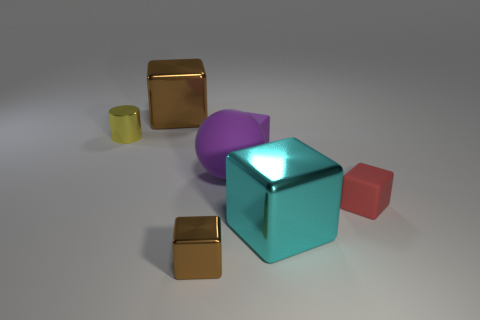There is a thing that is the same color as the small metal block; what is its material?
Provide a short and direct response. Metal. There is a big shiny object that is behind the cyan object; is its shape the same as the large object that is in front of the rubber ball?
Offer a terse response. Yes. What number of other objects are the same color as the big matte thing?
Your answer should be very brief. 1. What material is the tiny brown thing in front of the metallic block that is to the left of the small object that is in front of the tiny red block?
Your answer should be very brief. Metal. There is a large object that is to the left of the tiny metal thing to the right of the yellow thing; what is its material?
Give a very brief answer. Metal. Are there fewer tiny purple things that are to the right of the large purple object than brown matte cylinders?
Your answer should be compact. No. The tiny metal thing that is behind the cyan shiny block has what shape?
Offer a very short reply. Cylinder. Is the size of the shiny cylinder the same as the brown object that is behind the tiny purple matte thing?
Ensure brevity in your answer.  No. Is there a purple ball made of the same material as the purple cube?
Give a very brief answer. Yes. What number of cylinders are either big cyan things or red matte objects?
Give a very brief answer. 0. 